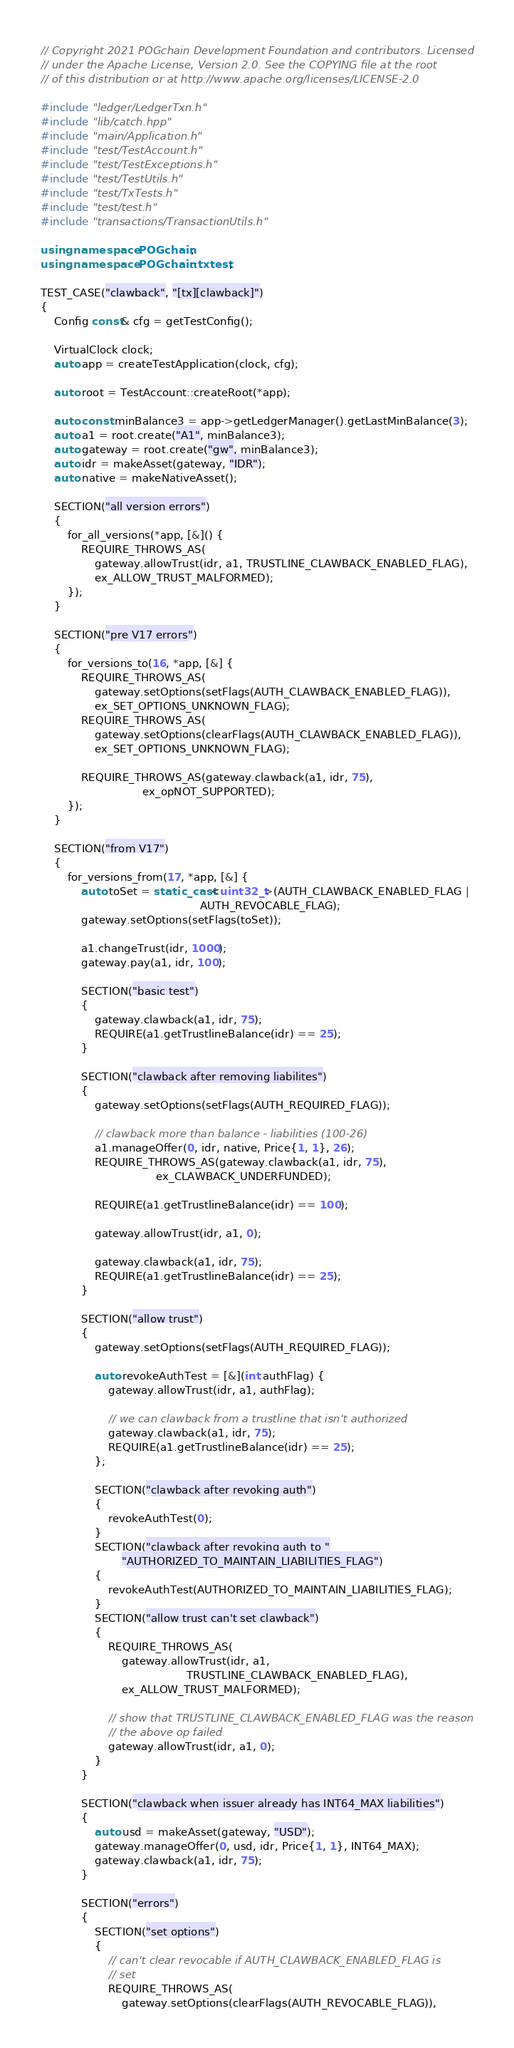Convert code to text. <code><loc_0><loc_0><loc_500><loc_500><_C++_>// Copyright 2021 POGchain Development Foundation and contributors. Licensed
// under the Apache License, Version 2.0. See the COPYING file at the root
// of this distribution or at http://www.apache.org/licenses/LICENSE-2.0

#include "ledger/LedgerTxn.h"
#include "lib/catch.hpp"
#include "main/Application.h"
#include "test/TestAccount.h"
#include "test/TestExceptions.h"
#include "test/TestUtils.h"
#include "test/TxTests.h"
#include "test/test.h"
#include "transactions/TransactionUtils.h"

using namespace POGchain;
using namespace POGchain::txtest;

TEST_CASE("clawback", "[tx][clawback]")
{
    Config const& cfg = getTestConfig();

    VirtualClock clock;
    auto app = createTestApplication(clock, cfg);

    auto root = TestAccount::createRoot(*app);

    auto const minBalance3 = app->getLedgerManager().getLastMinBalance(3);
    auto a1 = root.create("A1", minBalance3);
    auto gateway = root.create("gw", minBalance3);
    auto idr = makeAsset(gateway, "IDR");
    auto native = makeNativeAsset();

    SECTION("all version errors")
    {
        for_all_versions(*app, [&]() {
            REQUIRE_THROWS_AS(
                gateway.allowTrust(idr, a1, TRUSTLINE_CLAWBACK_ENABLED_FLAG),
                ex_ALLOW_TRUST_MALFORMED);
        });
    }

    SECTION("pre V17 errors")
    {
        for_versions_to(16, *app, [&] {
            REQUIRE_THROWS_AS(
                gateway.setOptions(setFlags(AUTH_CLAWBACK_ENABLED_FLAG)),
                ex_SET_OPTIONS_UNKNOWN_FLAG);
            REQUIRE_THROWS_AS(
                gateway.setOptions(clearFlags(AUTH_CLAWBACK_ENABLED_FLAG)),
                ex_SET_OPTIONS_UNKNOWN_FLAG);

            REQUIRE_THROWS_AS(gateway.clawback(a1, idr, 75),
                              ex_opNOT_SUPPORTED);
        });
    }

    SECTION("from V17")
    {
        for_versions_from(17, *app, [&] {
            auto toSet = static_cast<uint32_t>(AUTH_CLAWBACK_ENABLED_FLAG |
                                               AUTH_REVOCABLE_FLAG);
            gateway.setOptions(setFlags(toSet));

            a1.changeTrust(idr, 1000);
            gateway.pay(a1, idr, 100);

            SECTION("basic test")
            {
                gateway.clawback(a1, idr, 75);
                REQUIRE(a1.getTrustlineBalance(idr) == 25);
            }

            SECTION("clawback after removing liabilites")
            {
                gateway.setOptions(setFlags(AUTH_REQUIRED_FLAG));

                // clawback more than balance - liabilities (100-26)
                a1.manageOffer(0, idr, native, Price{1, 1}, 26);
                REQUIRE_THROWS_AS(gateway.clawback(a1, idr, 75),
                                  ex_CLAWBACK_UNDERFUNDED);

                REQUIRE(a1.getTrustlineBalance(idr) == 100);

                gateway.allowTrust(idr, a1, 0);

                gateway.clawback(a1, idr, 75);
                REQUIRE(a1.getTrustlineBalance(idr) == 25);
            }

            SECTION("allow trust")
            {
                gateway.setOptions(setFlags(AUTH_REQUIRED_FLAG));

                auto revokeAuthTest = [&](int authFlag) {
                    gateway.allowTrust(idr, a1, authFlag);

                    // we can clawback from a trustline that isn't authorized
                    gateway.clawback(a1, idr, 75);
                    REQUIRE(a1.getTrustlineBalance(idr) == 25);
                };

                SECTION("clawback after revoking auth")
                {
                    revokeAuthTest(0);
                }
                SECTION("clawback after revoking auth to "
                        "AUTHORIZED_TO_MAINTAIN_LIABILITIES_FLAG")
                {
                    revokeAuthTest(AUTHORIZED_TO_MAINTAIN_LIABILITIES_FLAG);
                }
                SECTION("allow trust can't set clawback")
                {
                    REQUIRE_THROWS_AS(
                        gateway.allowTrust(idr, a1,
                                           TRUSTLINE_CLAWBACK_ENABLED_FLAG),
                        ex_ALLOW_TRUST_MALFORMED);

                    // show that TRUSTLINE_CLAWBACK_ENABLED_FLAG was the reason
                    // the above op failed
                    gateway.allowTrust(idr, a1, 0);
                }
            }

            SECTION("clawback when issuer already has INT64_MAX liabilities")
            {
                auto usd = makeAsset(gateway, "USD");
                gateway.manageOffer(0, usd, idr, Price{1, 1}, INT64_MAX);
                gateway.clawback(a1, idr, 75);
            }

            SECTION("errors")
            {
                SECTION("set options")
                {
                    // can't clear revocable if AUTH_CLAWBACK_ENABLED_FLAG is
                    // set
                    REQUIRE_THROWS_AS(
                        gateway.setOptions(clearFlags(AUTH_REVOCABLE_FLAG)),</code> 